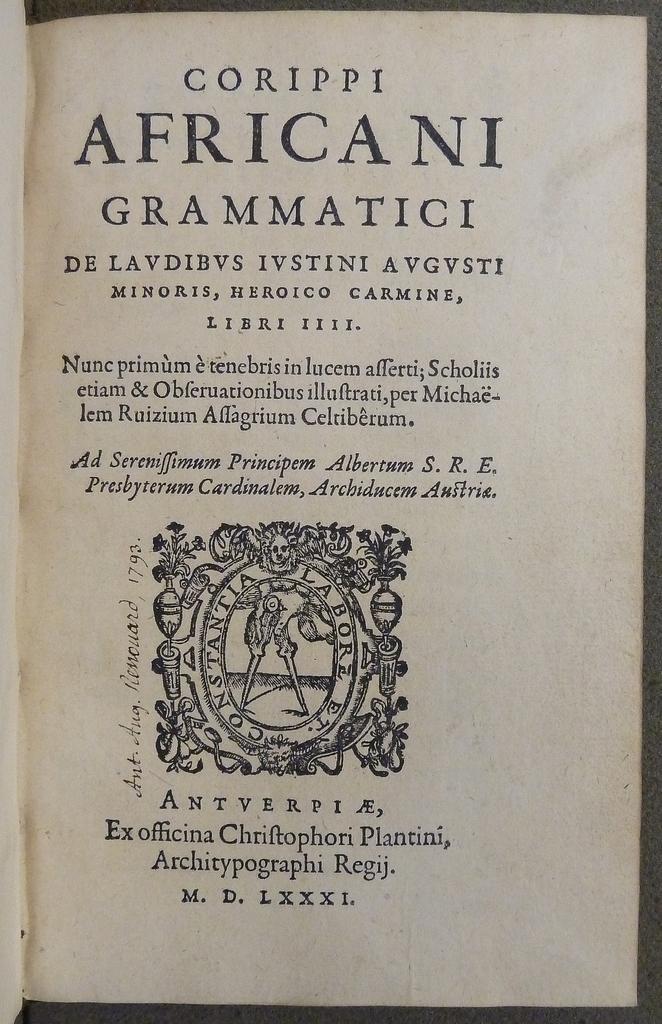<image>
Present a compact description of the photo's key features. The book contains the roman numerals at the bottom LXXXI. 